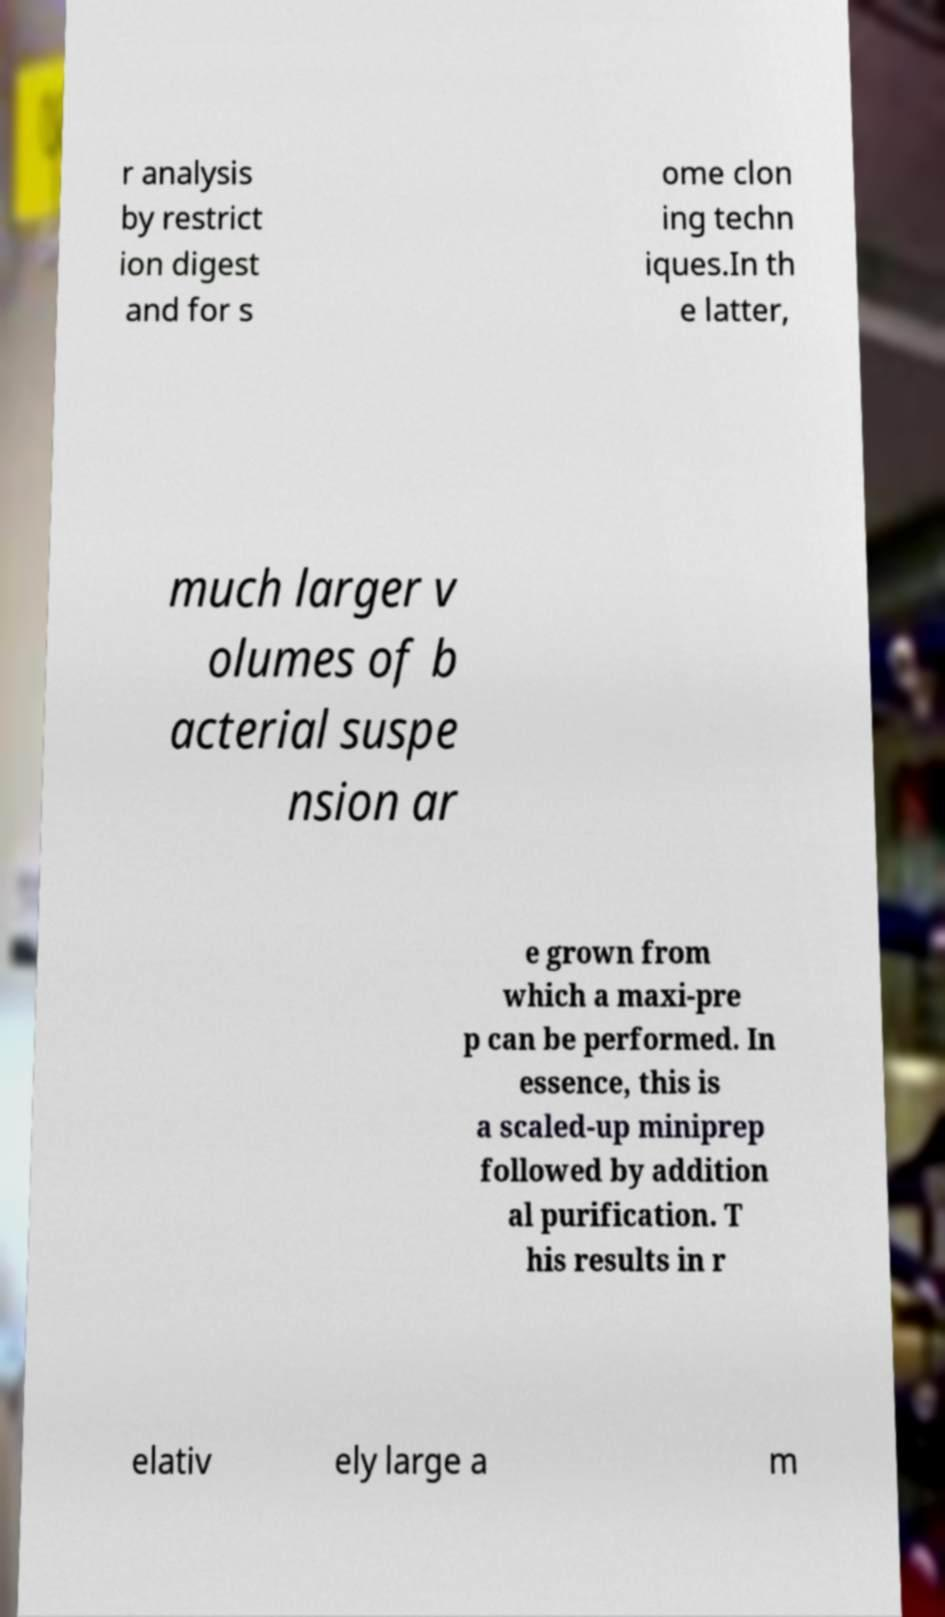There's text embedded in this image that I need extracted. Can you transcribe it verbatim? r analysis by restrict ion digest and for s ome clon ing techn iques.In th e latter, much larger v olumes of b acterial suspe nsion ar e grown from which a maxi-pre p can be performed. In essence, this is a scaled-up miniprep followed by addition al purification. T his results in r elativ ely large a m 